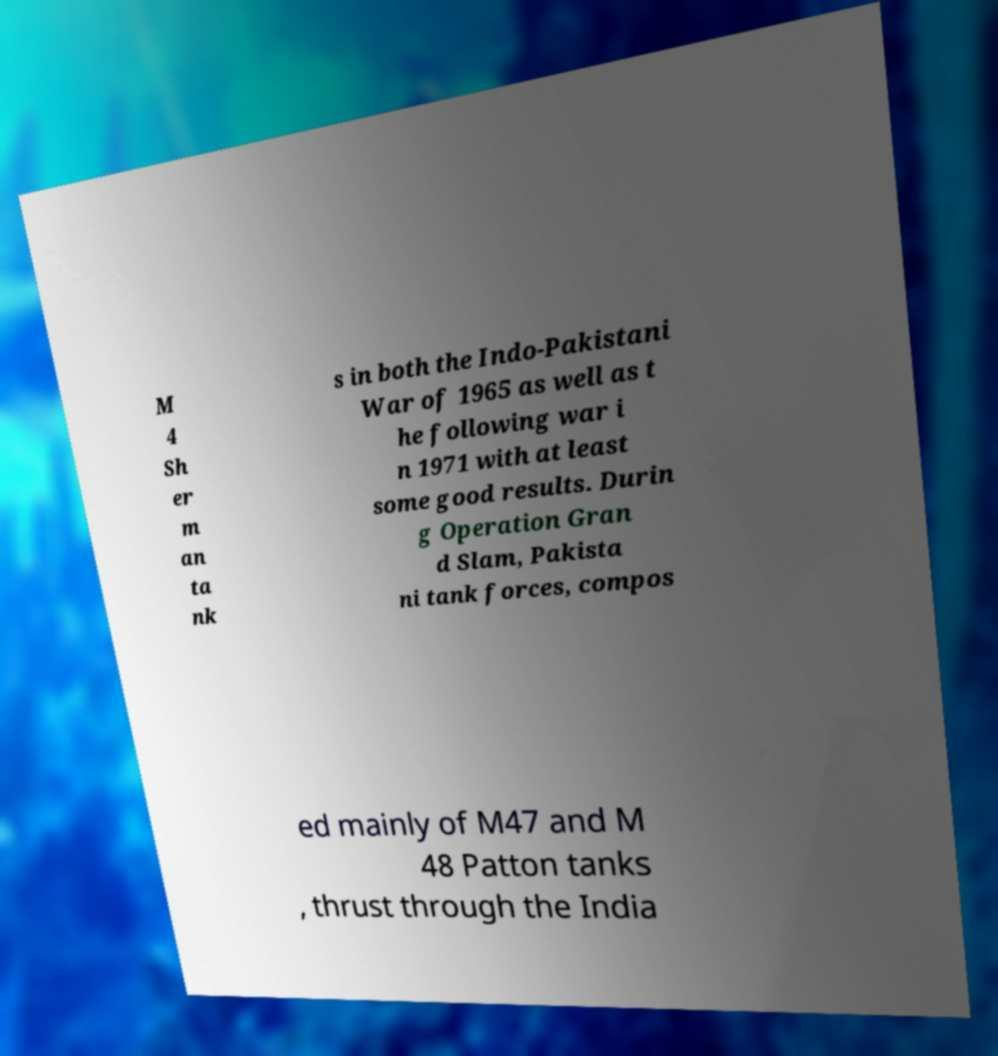Can you accurately transcribe the text from the provided image for me? M 4 Sh er m an ta nk s in both the Indo-Pakistani War of 1965 as well as t he following war i n 1971 with at least some good results. Durin g Operation Gran d Slam, Pakista ni tank forces, compos ed mainly of M47 and M 48 Patton tanks , thrust through the India 